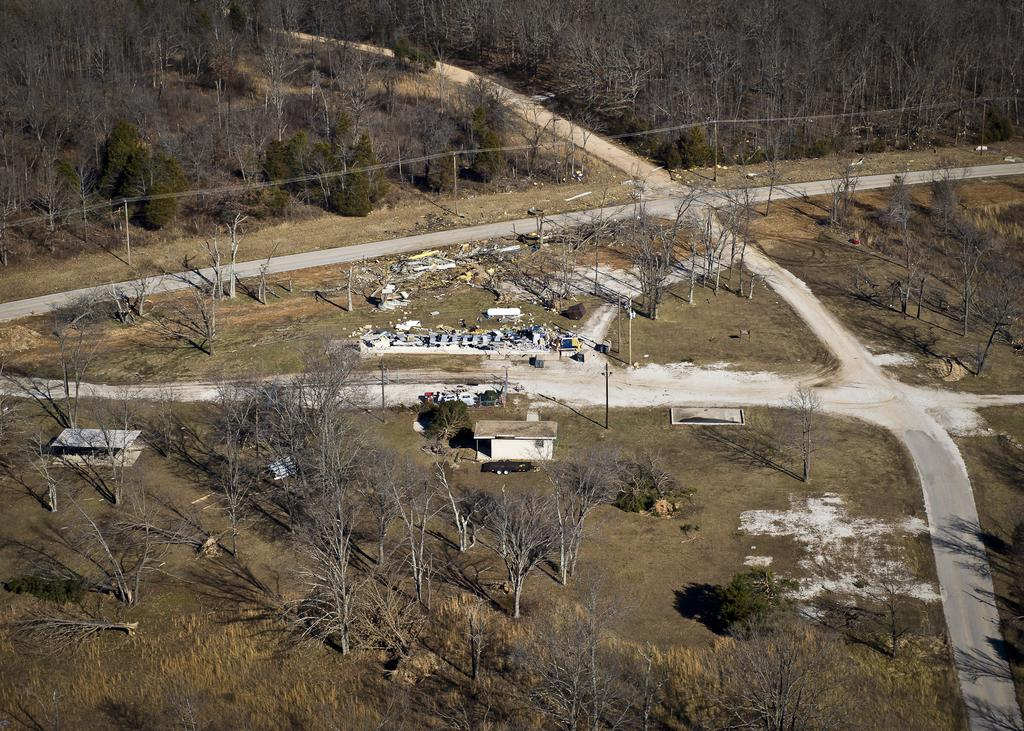What type of vegetation is present in the image? There are many trees in the image. What can be seen at the bottom of the image? There is ground visible at the bottom of the image, and there is green grass there as well. What type of structures are present in the image? There are small houses in the image. What type of hat can be seen on the fish in the image? There are no fish or hats present in the image; it features trees, ground, grass, and small houses. 